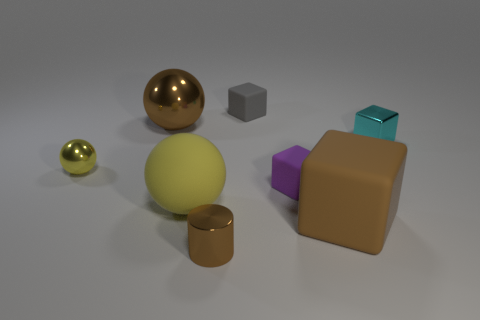What material is the gray block that is the same size as the purple rubber block?
Offer a very short reply. Rubber. What number of objects are either metallic things left of the small cyan object or small objects behind the brown cylinder?
Make the answer very short. 6. Is the number of brown things that are to the right of the large yellow thing greater than the number of brown blocks?
Your response must be concise. Yes. How many other objects are there of the same shape as the cyan shiny thing?
Offer a terse response. 3. The thing that is in front of the purple matte cube and on the right side of the small gray matte block is made of what material?
Ensure brevity in your answer.  Rubber. What number of objects are either large brown balls or large objects?
Make the answer very short. 3. Are there more small shiny cylinders than big purple objects?
Keep it short and to the point. Yes. There is a metal thing that is to the right of the brown shiny cylinder on the right side of the large yellow matte thing; what is its size?
Provide a succinct answer. Small. There is another shiny object that is the same shape as the small purple object; what color is it?
Ensure brevity in your answer.  Cyan. How big is the yellow matte thing?
Keep it short and to the point. Large. 